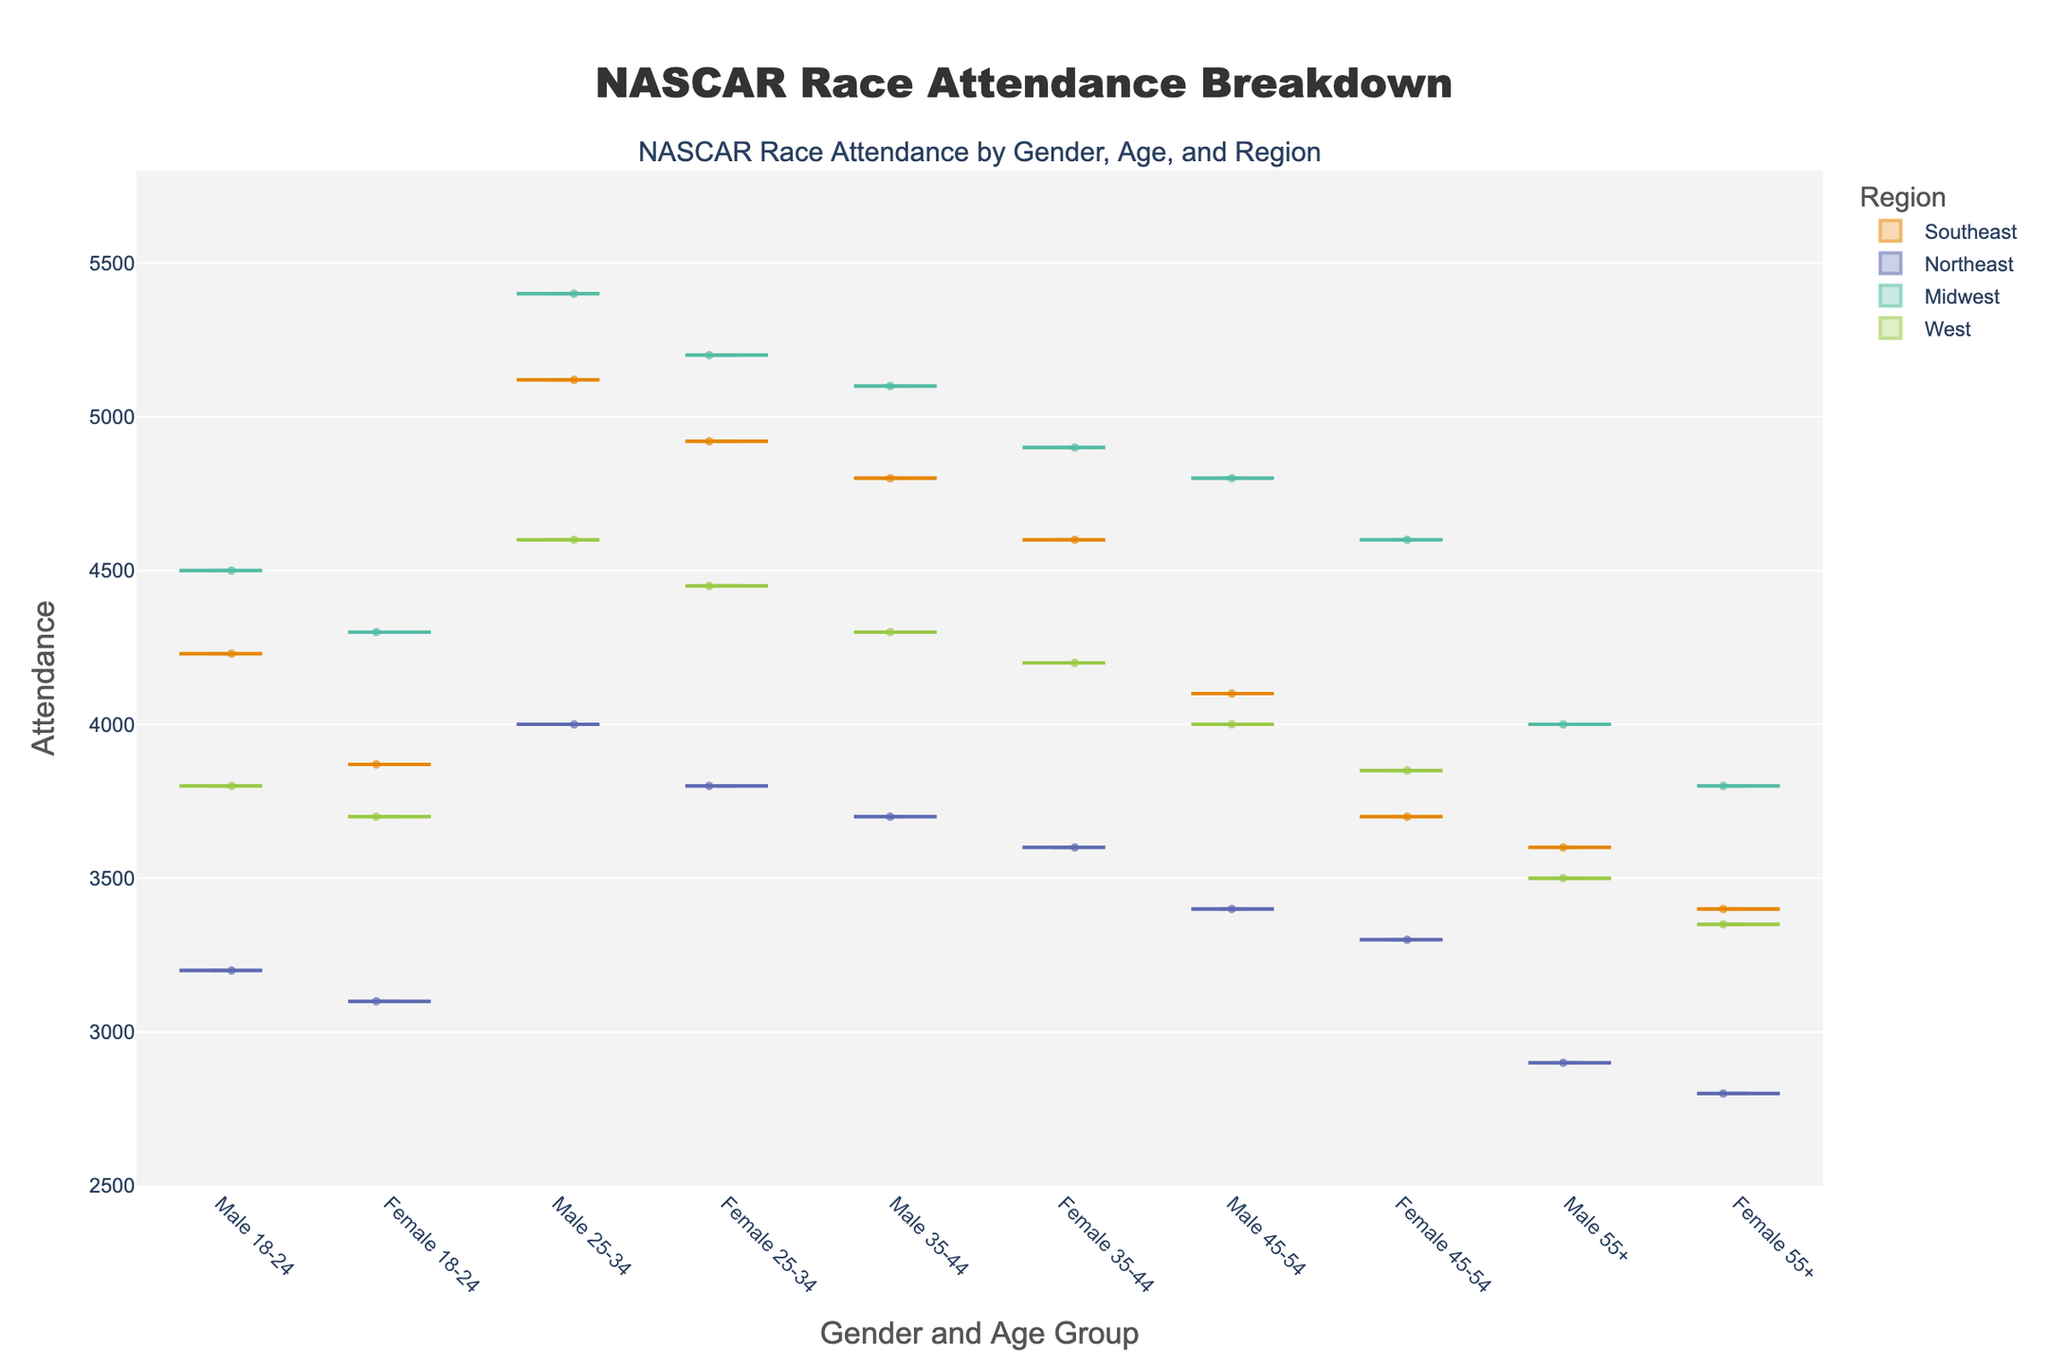What's the title of the figure? The title is found at the top center of the figure. It reads "NASCAR Race Attendance Breakdown".
Answer: NASCAR Race Attendance Breakdown What are the axes labels? The x-axis label is "Gender and Age Group," indicating categories combining gender and age; the y-axis label is "Attendance," representing the number of attendees.
Answer: Gender and Age Group, Attendance Which region has the highest attendance for the '25-34 Male' group? By looking at the highest point on the violin plot for the '25-34 Male' category, we can see that the Midwest region has the highest attendance.
Answer: Midwest What's the attendance range shown on the y-axis? The range of attendance on the y-axis can be seen from the lowest to the highest tick marks. In this case, it ranges from 2500 to 5800.
Answer: 2500 to 5800 Which age group has the most attendance variability for females in the Southeast region? By comparing the width of the violin plots for females in different age groups within the Southeast region, we can observe that the '25-34' age group has the most variability.
Answer: 25-34 Between males and females aged 35-44 in the Northeast region, who has higher attendance? Comparing the heights of the violin plots for '35-44 Male' and '35-44 Female' in the Northeast region, '35-44 Male' has higher attendance.
Answer: Males In the West region, which gender-age group combination has the lowest attendance? Analyzing the lowest points on the violin plots for the West region, the '55+ Female' group has the lowest attendance.
Answer: 55+ Female Is there a visible region with consistently higher attendance across all age groups and genders? By observing the violin plots for each region side by side, the Southeast region appears to have consistently higher attendance across all categories.
Answer: Southeast What’s the mean attendance for the '18-24 Female' group in the Midwest region? The mean line within the '18-24 Female' violin plot for the Midwest region indicates the average attendance, which can be visually estimated from its position within the y-axis range.
Answer: Approximately 4300 Considering the '45-54' age group, do males or females show greater attendance variability in the Midwest region? Checking the width of the violin plots around the '45-54 Male' and '45-54 Female' categories, the males show greater attendance variability in the Midwest region.
Answer: Males 